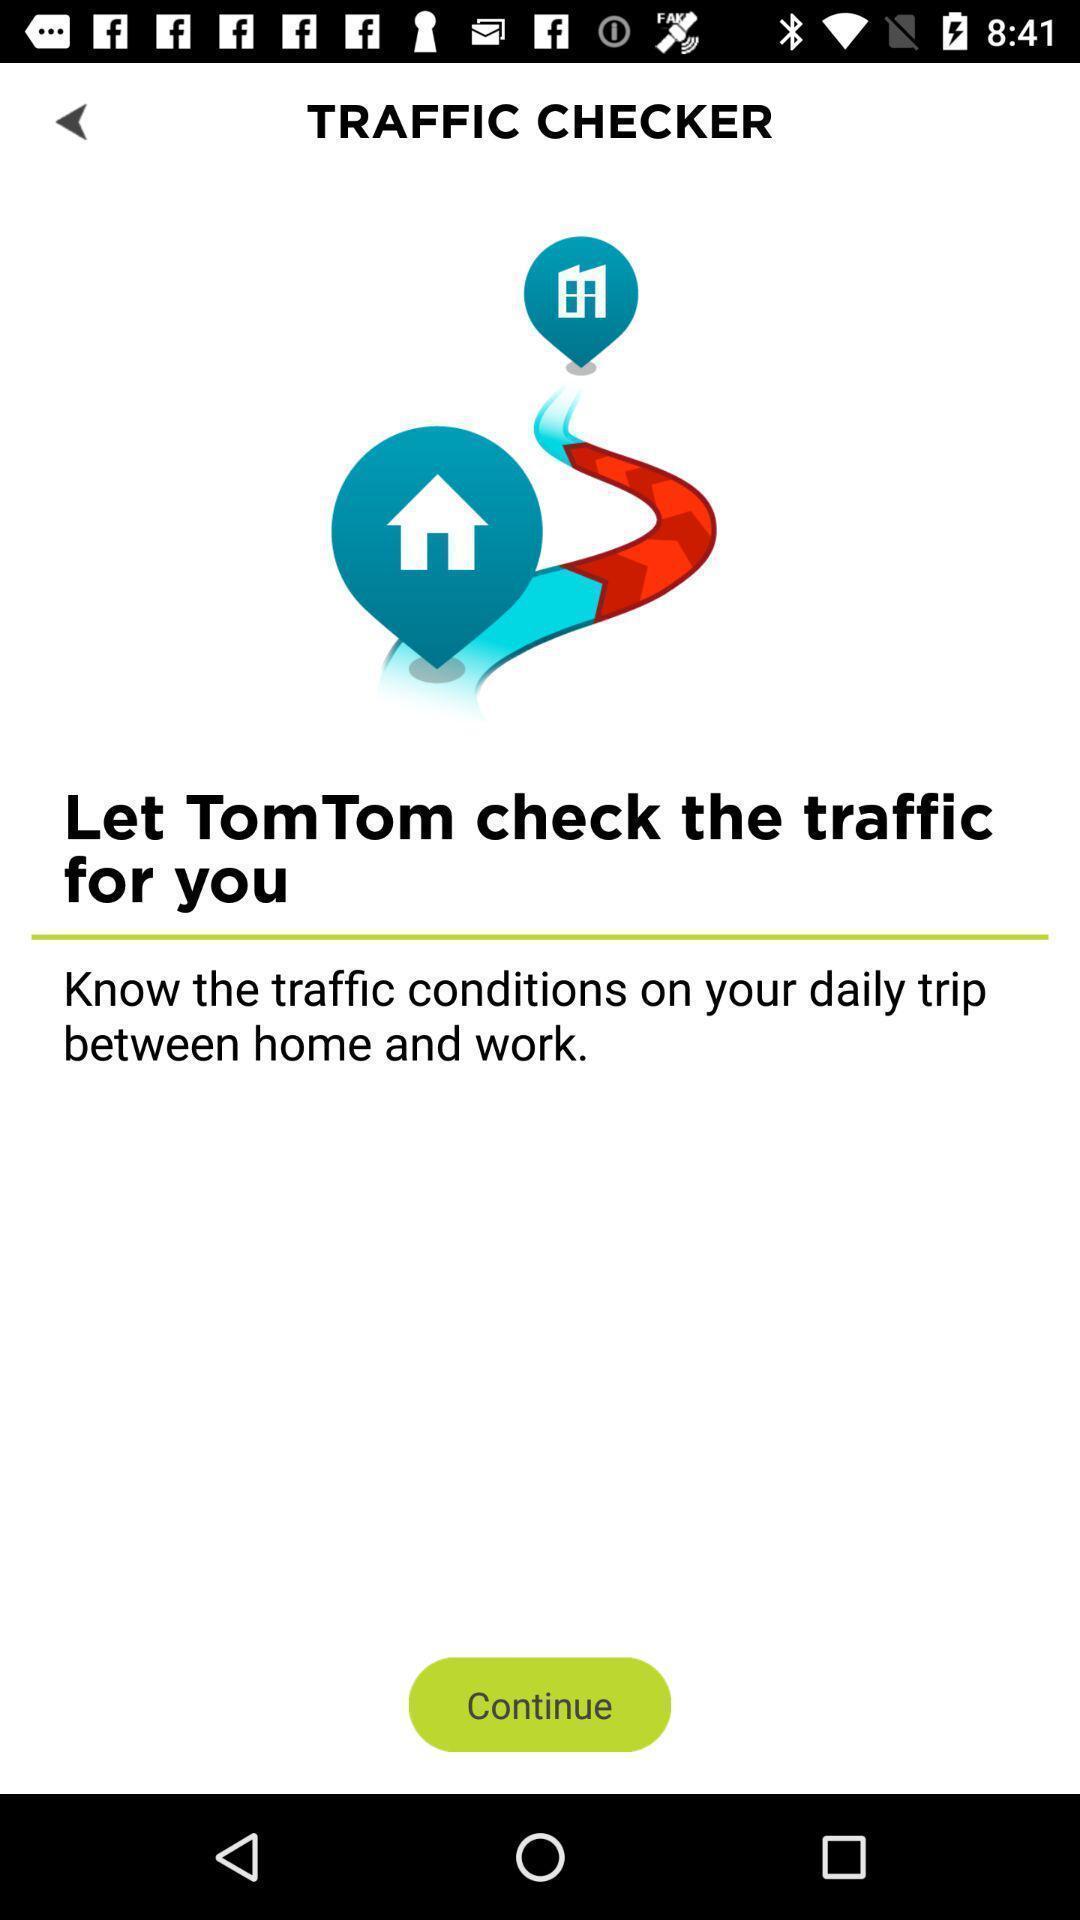Summarize the main components in this picture. Screen shows about a traffic checker. 